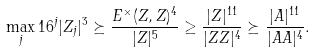Convert formula to latex. <formula><loc_0><loc_0><loc_500><loc_500>\max _ { j } 1 6 ^ { j } | Z _ { j } | ^ { 3 } \succeq \frac { E ^ { \times } ( Z , Z ) ^ { 4 } } { | Z | ^ { 5 } } \geq \frac { | Z | ^ { 1 1 } } { | Z Z | ^ { 4 } } \succeq \frac { | A | ^ { 1 1 } } { | A A | ^ { 4 } } .</formula> 